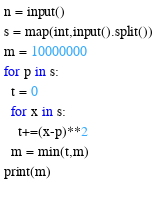Convert code to text. <code><loc_0><loc_0><loc_500><loc_500><_Python_>n = input()
s = map(int,input().split())
m = 10000000
for p in s:
  t = 0
  for x in s:
    t+=(x-p)**2
  m = min(t,m)
print(m)
    </code> 